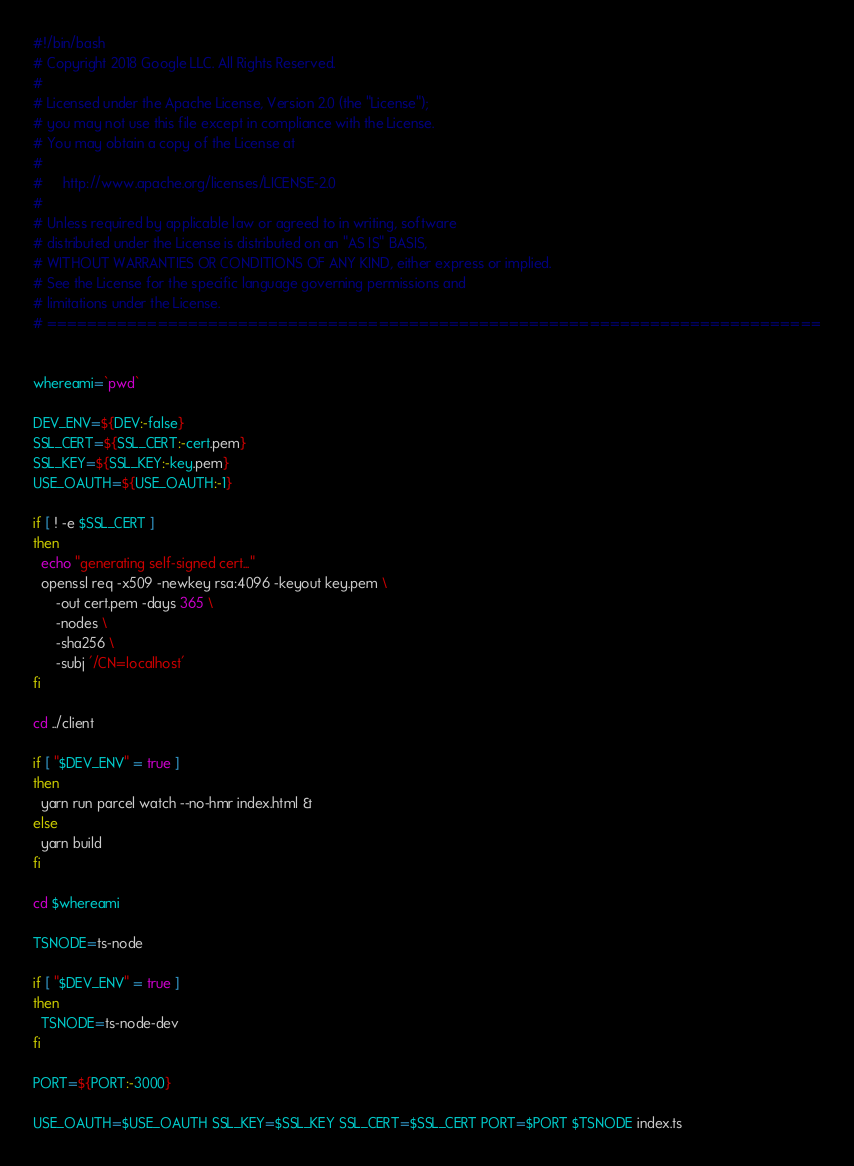<code> <loc_0><loc_0><loc_500><loc_500><_Bash_>#!/bin/bash
# Copyright 2018 Google LLC. All Rights Reserved.
#
# Licensed under the Apache License, Version 2.0 (the "License");
# you may not use this file except in compliance with the License.
# You may obtain a copy of the License at
#
#     http://www.apache.org/licenses/LICENSE-2.0
#
# Unless required by applicable law or agreed to in writing, software
# distributed under the License is distributed on an "AS IS" BASIS,
# WITHOUT WARRANTIES OR CONDITIONS OF ANY KIND, either express or implied.
# See the License for the specific language governing permissions and
# limitations under the License.
# =============================================================================


whereami=`pwd`

DEV_ENV=${DEV:-false}
SSL_CERT=${SSL_CERT:-cert.pem}
SSL_KEY=${SSL_KEY:-key.pem}
USE_OAUTH=${USE_OAUTH:-1}

if [ ! -e $SSL_CERT ]
then
  echo "generating self-signed cert..."
  openssl req -x509 -newkey rsa:4096 -keyout key.pem \
      -out cert.pem -days 365 \
      -nodes \
      -sha256 \
      -subj '/CN=localhost'
fi

cd ../client

if [ "$DEV_ENV" = true ]
then
  yarn run parcel watch --no-hmr index.html &
else
  yarn build
fi

cd $whereami

TSNODE=ts-node

if [ "$DEV_ENV" = true ]
then
  TSNODE=ts-node-dev
fi

PORT=${PORT:-3000}

USE_OAUTH=$USE_OAUTH SSL_KEY=$SSL_KEY SSL_CERT=$SSL_CERT PORT=$PORT $TSNODE index.ts
</code> 